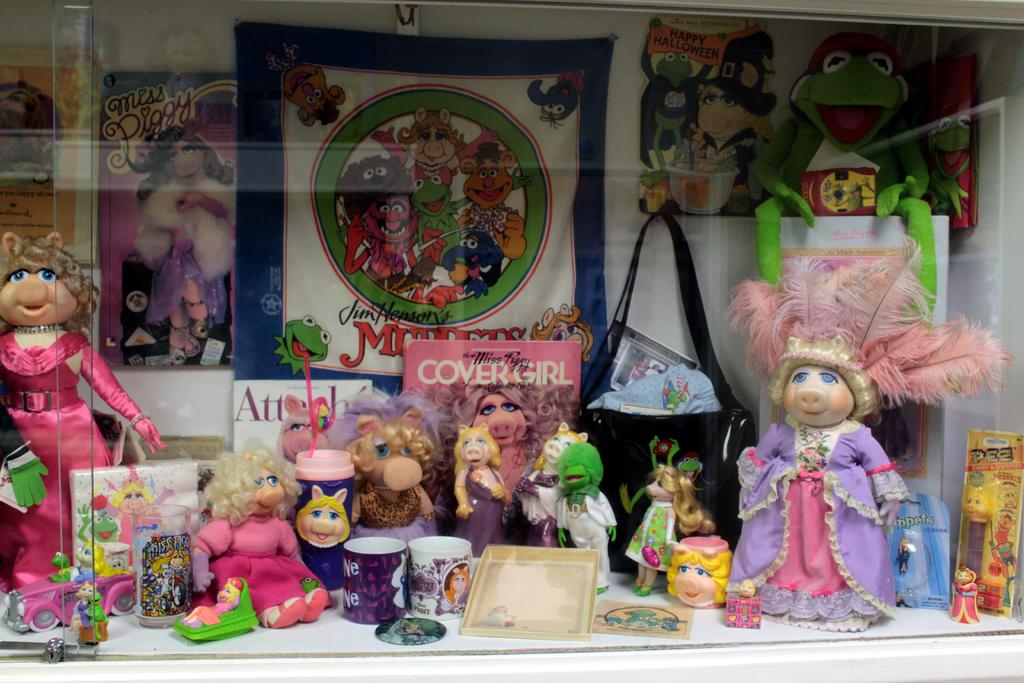<image>
Relay a brief, clear account of the picture shown. A pez dispenser on a shelf with Mrs. Piggy dolls 